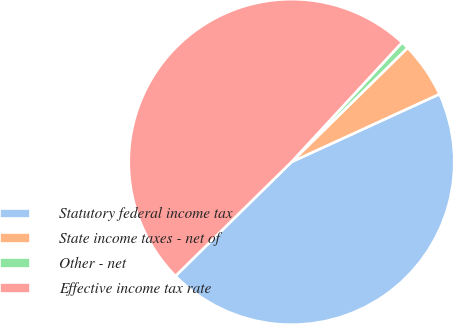Convert chart to OTSL. <chart><loc_0><loc_0><loc_500><loc_500><pie_chart><fcel>Statutory federal income tax<fcel>State income taxes - net of<fcel>Other - net<fcel>Effective income tax rate<nl><fcel>44.48%<fcel>5.52%<fcel>0.76%<fcel>49.24%<nl></chart> 